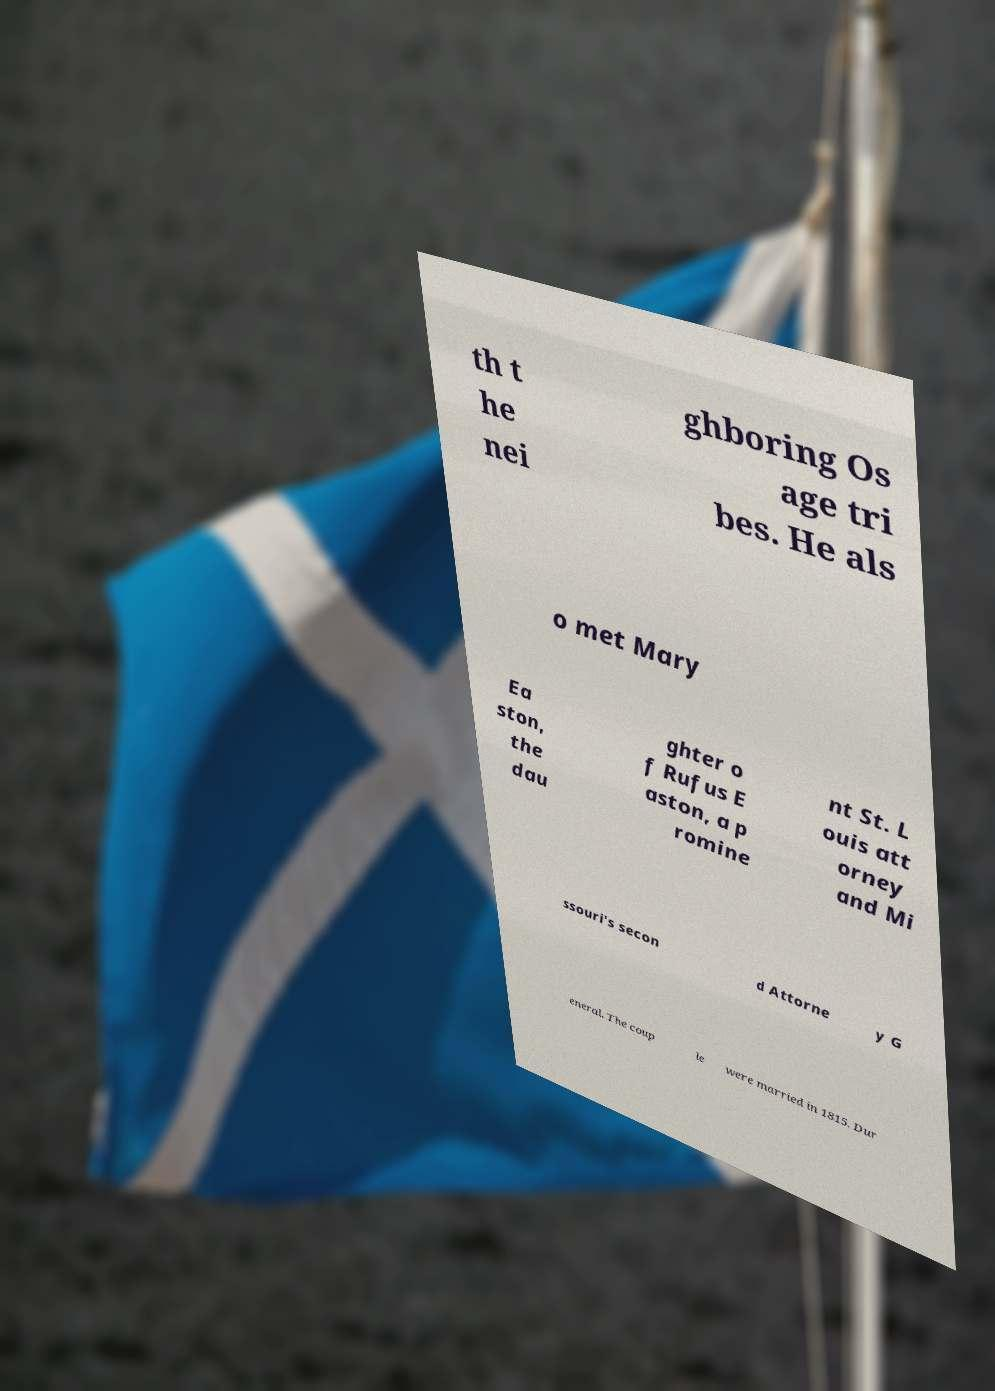Could you assist in decoding the text presented in this image and type it out clearly? th t he nei ghboring Os age tri bes. He als o met Mary Ea ston, the dau ghter o f Rufus E aston, a p romine nt St. L ouis att orney and Mi ssouri's secon d Attorne y G eneral. The coup le were married in 1815. Dur 